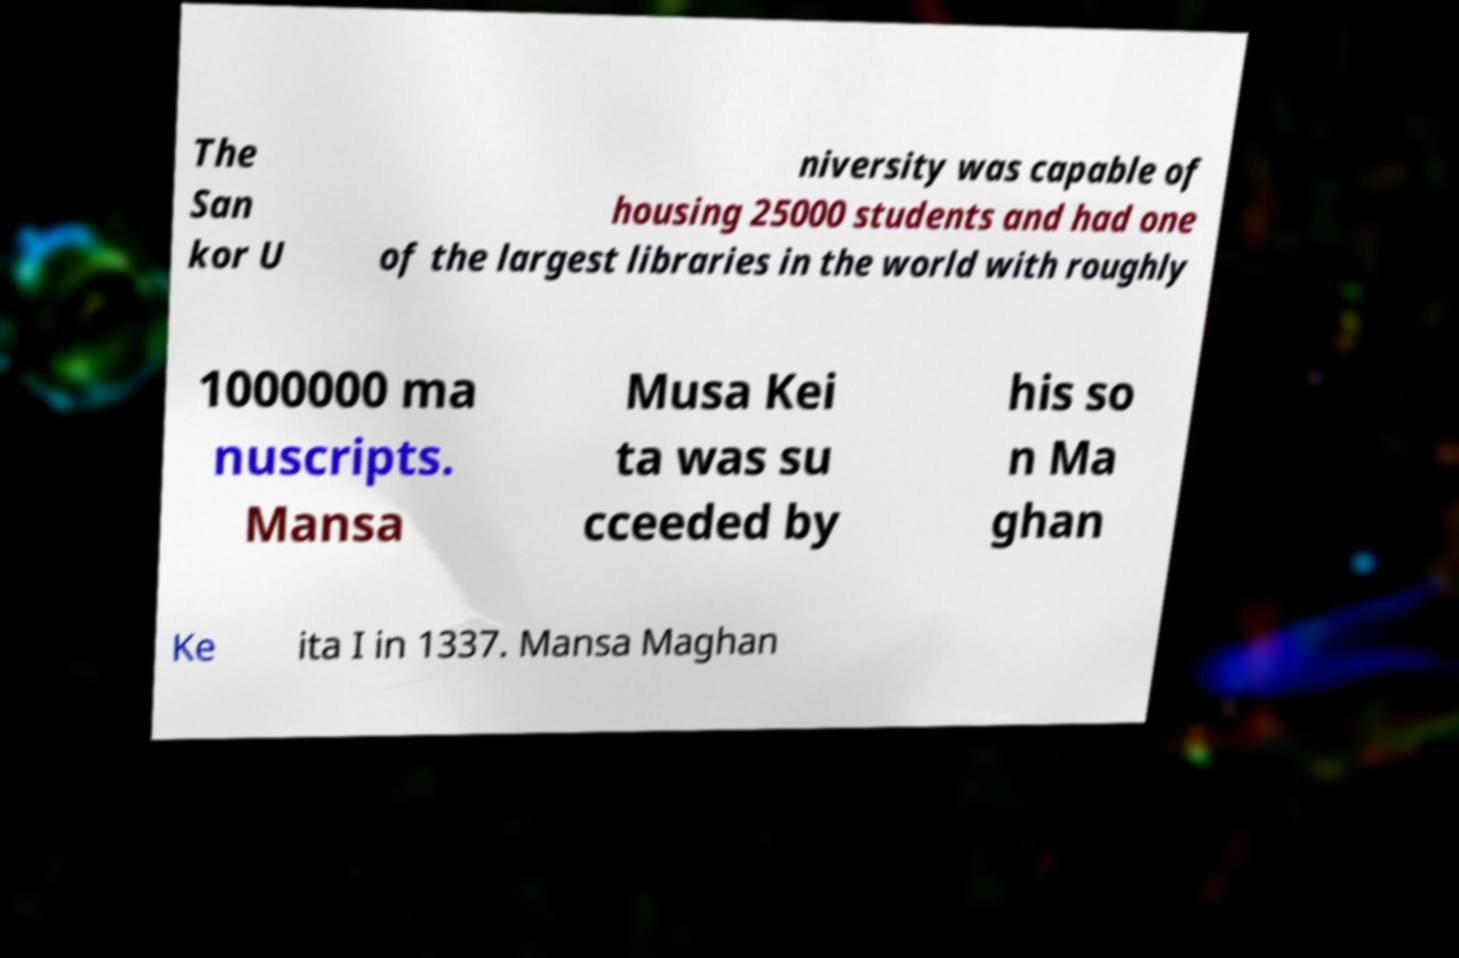Please read and relay the text visible in this image. What does it say? The San kor U niversity was capable of housing 25000 students and had one of the largest libraries in the world with roughly 1000000 ma nuscripts. Mansa Musa Kei ta was su cceeded by his so n Ma ghan Ke ita I in 1337. Mansa Maghan 